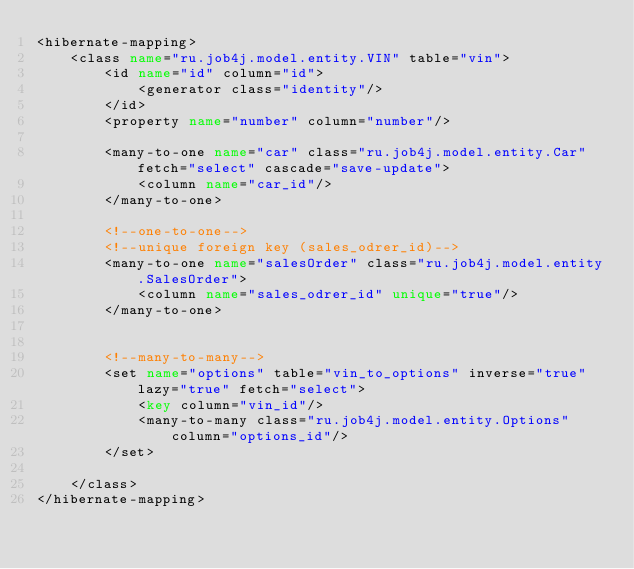Convert code to text. <code><loc_0><loc_0><loc_500><loc_500><_XML_><hibernate-mapping>
    <class name="ru.job4j.model.entity.VIN" table="vin">
        <id name="id" column="id">
            <generator class="identity"/>
        </id>
        <property name="number" column="number"/>

        <many-to-one name="car" class="ru.job4j.model.entity.Car" fetch="select" cascade="save-update">
            <column name="car_id"/>
        </many-to-one>

        <!--one-to-one-->
        <!--unique foreign key (sales_odrer_id)-->
        <many-to-one name="salesOrder" class="ru.job4j.model.entity.SalesOrder">
            <column name="sales_odrer_id" unique="true"/>
        </many-to-one>


        <!--many-to-many-->
        <set name="options" table="vin_to_options" inverse="true" lazy="true" fetch="select">
            <key column="vin_id"/>
            <many-to-many class="ru.job4j.model.entity.Options" column="options_id"/>
        </set>

    </class>
</hibernate-mapping></code> 